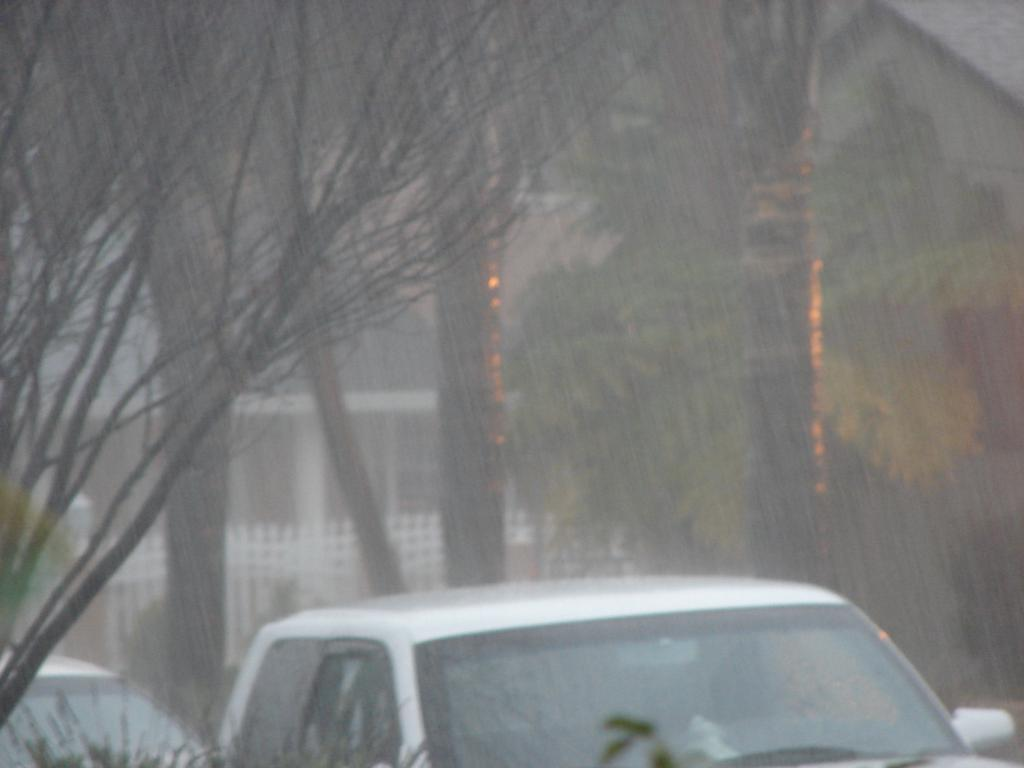What types of objects are in the image? There are vehicles in the image. What structure can be seen in the background? There is a building visible in the image. What is in front of the building? There is a fence in front of the building. What type of vegetation is present in the image? Trees are present in the image. What type of glove is being worn by the band in the image? There is no band or glove present in the image. What scene is being depicted in the image? The image does not depict a specific scene; it shows vehicles, a building, a fence, and trees. 